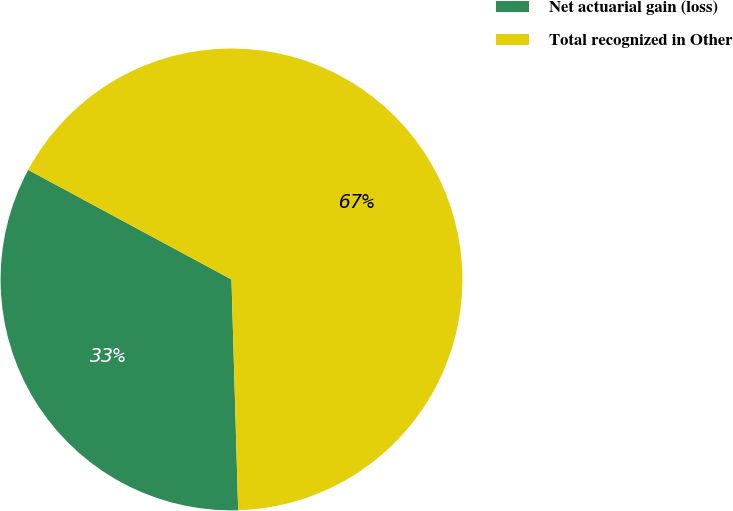Convert chart to OTSL. <chart><loc_0><loc_0><loc_500><loc_500><pie_chart><fcel>Net actuarial gain (loss)<fcel>Total recognized in Other<nl><fcel>33.33%<fcel>66.67%<nl></chart> 